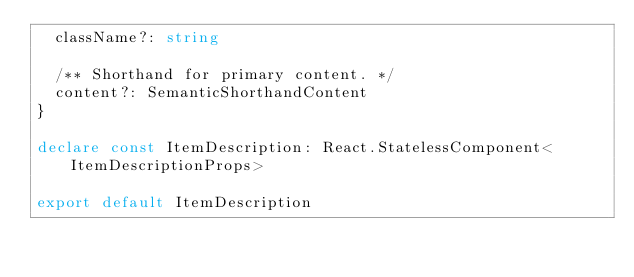Convert code to text. <code><loc_0><loc_0><loc_500><loc_500><_TypeScript_>  className?: string

  /** Shorthand for primary content. */
  content?: SemanticShorthandContent
}

declare const ItemDescription: React.StatelessComponent<ItemDescriptionProps>

export default ItemDescription
</code> 